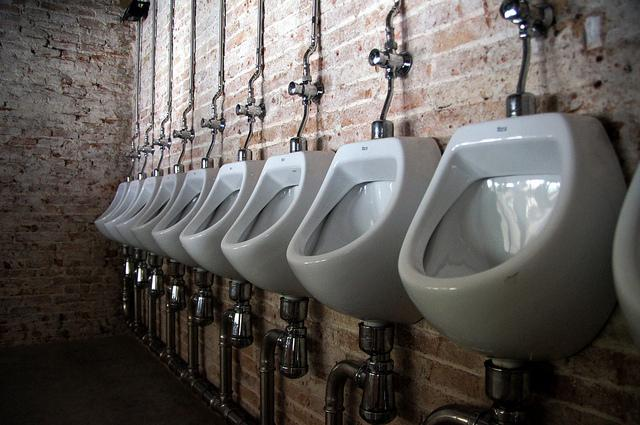What are these white objects used to hold?

Choices:
A) popcorn
B) urine
C) cats
D) bread urine 